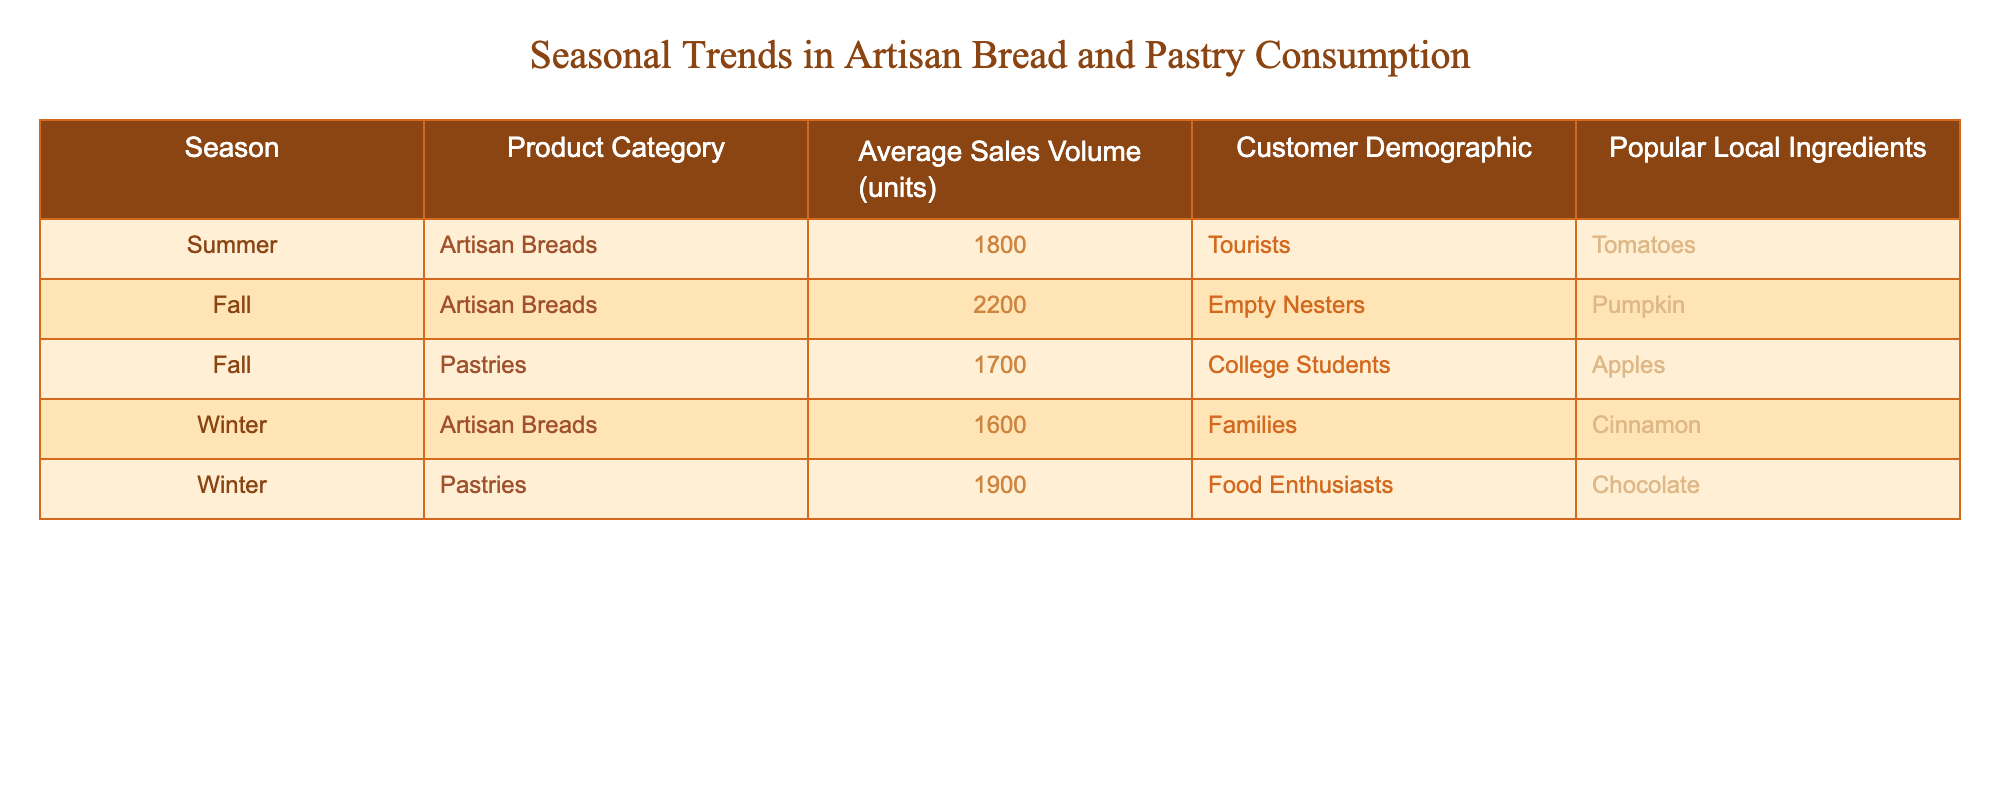What is the average sales volume of artisan breads in the fall? In the table, the average sales volume for artisan breads in the fall is stated as 2200 units, so we can directly reference that value.
Answer: 2200 What local ingredient is popular for pastries during winter? The table indicates that the local ingredient popular for pastries in winter is chocolate, as listed in that row.
Answer: Chocolate How many units of pastries were sold in fall? The table shows that 1700 units of pastries were sold in the fall, so we can directly confirm this data from that row.
Answer: 1700 Which customer demographic purchases the most artisan breads in summer? According to the table, tourists are the customer demographic that purchases the most artisan breads during the summer, as indicated under that season's row.
Answer: Tourists Which season had the highest average sales volume for pastries? By analyzing the table, we see that winter had the highest average sales volume for pastries, with 1900 units sold, compared to 1700 units in fall.
Answer: Winter How do the average sales volumes of artisan breads in summer and winter compare? The average sales volume of artisan breads in summer is 1800 units, while in winter it is 1600 units. When we subtract the winter volume from summer, we find that 1800 - 1600 = 200, meaning summer has a higher sales volume.
Answer: Summer is higher by 200 units If we consider all the sales volumes for pastries and artisan breads, what is the total sales volume for fall? Summing the sales volumes for fall, we have artisan breads at 2200 units and pastries at 1700 units. Adding these gives us 2200 + 1700 = 3900, which is the total for fall.
Answer: 3900 Is cinnamon a popular local ingredient for artisan breads in summer? The table indicates that the popular local ingredient for artisan breads in summer is tomatoes, not cinnamon. Therefore, the statement is false.
Answer: No During which season are families the primary customer demographic for artisan breads? According to the table, families purchase artisan breads during winter, as denoted in that specific data row.
Answer: Winter What is the average sales volume for pastries across all seasons? The sales volumes for pastries are 1700 in fall and 1900 in winter. Summer data is not listed for pastries, so for an average: we add 1700 + 1900 = 3600, and divide by 2 to get an average of 1800 units. This assumes we are averaging only the two given seasons.
Answer: 1800 